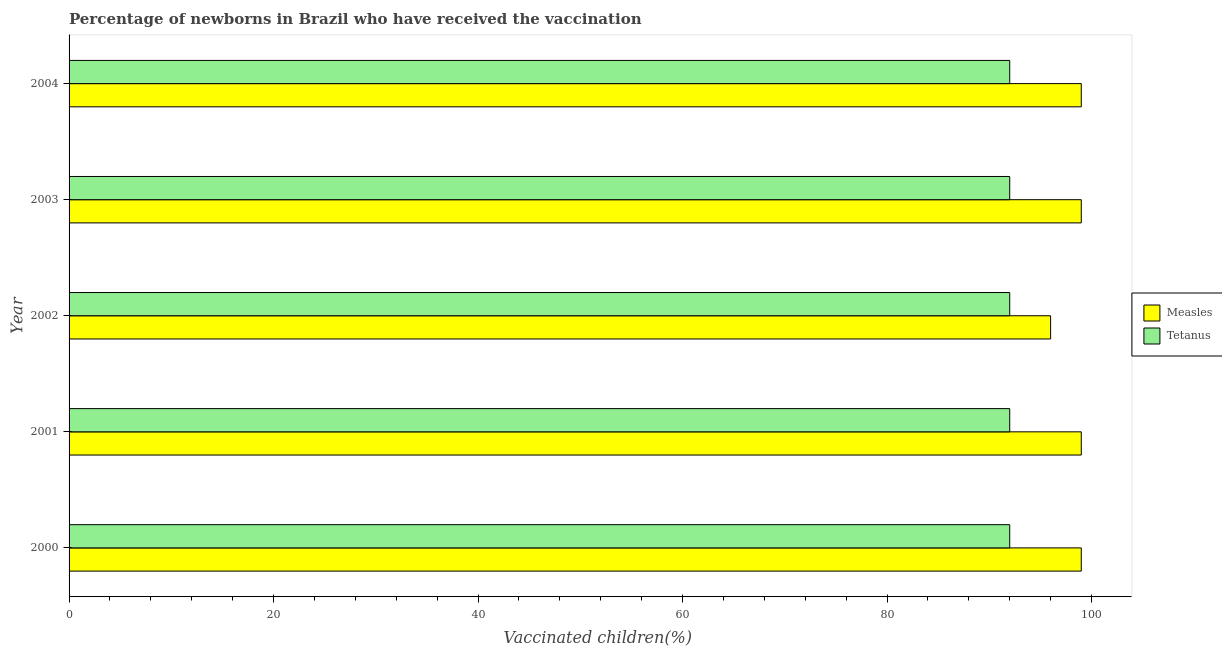How many different coloured bars are there?
Your response must be concise. 2. How many groups of bars are there?
Offer a very short reply. 5. Are the number of bars on each tick of the Y-axis equal?
Offer a terse response. Yes. How many bars are there on the 2nd tick from the top?
Provide a short and direct response. 2. In how many cases, is the number of bars for a given year not equal to the number of legend labels?
Ensure brevity in your answer.  0. What is the percentage of newborns who received vaccination for tetanus in 2004?
Your answer should be compact. 92. Across all years, what is the maximum percentage of newborns who received vaccination for measles?
Ensure brevity in your answer.  99. Across all years, what is the minimum percentage of newborns who received vaccination for tetanus?
Your answer should be very brief. 92. In which year was the percentage of newborns who received vaccination for measles minimum?
Offer a very short reply. 2002. What is the total percentage of newborns who received vaccination for measles in the graph?
Keep it short and to the point. 492. What is the difference between the percentage of newborns who received vaccination for tetanus in 2000 and the percentage of newborns who received vaccination for measles in 2001?
Make the answer very short. -7. What is the average percentage of newborns who received vaccination for tetanus per year?
Your answer should be very brief. 92. In the year 2002, what is the difference between the percentage of newborns who received vaccination for measles and percentage of newborns who received vaccination for tetanus?
Provide a succinct answer. 4. Is the percentage of newborns who received vaccination for tetanus in 2000 less than that in 2003?
Offer a terse response. No. What does the 2nd bar from the top in 2003 represents?
Make the answer very short. Measles. What does the 1st bar from the bottom in 2002 represents?
Your answer should be compact. Measles. How many years are there in the graph?
Keep it short and to the point. 5. What is the difference between two consecutive major ticks on the X-axis?
Your answer should be very brief. 20. Are the values on the major ticks of X-axis written in scientific E-notation?
Ensure brevity in your answer.  No. Where does the legend appear in the graph?
Your response must be concise. Center right. How are the legend labels stacked?
Make the answer very short. Vertical. What is the title of the graph?
Give a very brief answer. Percentage of newborns in Brazil who have received the vaccination. What is the label or title of the X-axis?
Offer a very short reply. Vaccinated children(%)
. What is the label or title of the Y-axis?
Make the answer very short. Year. What is the Vaccinated children(%)
 in Measles in 2000?
Keep it short and to the point. 99. What is the Vaccinated children(%)
 of Tetanus in 2000?
Keep it short and to the point. 92. What is the Vaccinated children(%)
 of Tetanus in 2001?
Ensure brevity in your answer.  92. What is the Vaccinated children(%)
 of Measles in 2002?
Provide a short and direct response. 96. What is the Vaccinated children(%)
 of Tetanus in 2002?
Give a very brief answer. 92. What is the Vaccinated children(%)
 of Measles in 2003?
Ensure brevity in your answer.  99. What is the Vaccinated children(%)
 of Tetanus in 2003?
Offer a very short reply. 92. What is the Vaccinated children(%)
 of Measles in 2004?
Keep it short and to the point. 99. What is the Vaccinated children(%)
 in Tetanus in 2004?
Ensure brevity in your answer.  92. Across all years, what is the maximum Vaccinated children(%)
 in Measles?
Your answer should be compact. 99. Across all years, what is the maximum Vaccinated children(%)
 in Tetanus?
Provide a succinct answer. 92. Across all years, what is the minimum Vaccinated children(%)
 of Measles?
Make the answer very short. 96. Across all years, what is the minimum Vaccinated children(%)
 in Tetanus?
Offer a very short reply. 92. What is the total Vaccinated children(%)
 of Measles in the graph?
Keep it short and to the point. 492. What is the total Vaccinated children(%)
 in Tetanus in the graph?
Provide a short and direct response. 460. What is the difference between the Vaccinated children(%)
 in Tetanus in 2000 and that in 2001?
Provide a succinct answer. 0. What is the difference between the Vaccinated children(%)
 of Tetanus in 2000 and that in 2002?
Provide a short and direct response. 0. What is the difference between the Vaccinated children(%)
 in Tetanus in 2000 and that in 2003?
Ensure brevity in your answer.  0. What is the difference between the Vaccinated children(%)
 of Measles in 2000 and that in 2004?
Your response must be concise. 0. What is the difference between the Vaccinated children(%)
 in Tetanus in 2000 and that in 2004?
Make the answer very short. 0. What is the difference between the Vaccinated children(%)
 in Measles in 2001 and that in 2002?
Your response must be concise. 3. What is the difference between the Vaccinated children(%)
 in Tetanus in 2001 and that in 2002?
Keep it short and to the point. 0. What is the difference between the Vaccinated children(%)
 in Measles in 2002 and that in 2003?
Your response must be concise. -3. What is the difference between the Vaccinated children(%)
 of Measles in 2002 and that in 2004?
Give a very brief answer. -3. What is the difference between the Vaccinated children(%)
 in Tetanus in 2002 and that in 2004?
Your answer should be compact. 0. What is the difference between the Vaccinated children(%)
 of Tetanus in 2003 and that in 2004?
Give a very brief answer. 0. What is the difference between the Vaccinated children(%)
 of Measles in 2000 and the Vaccinated children(%)
 of Tetanus in 2002?
Give a very brief answer. 7. What is the difference between the Vaccinated children(%)
 of Measles in 2000 and the Vaccinated children(%)
 of Tetanus in 2003?
Provide a succinct answer. 7. What is the difference between the Vaccinated children(%)
 in Measles in 2000 and the Vaccinated children(%)
 in Tetanus in 2004?
Ensure brevity in your answer.  7. What is the difference between the Vaccinated children(%)
 in Measles in 2001 and the Vaccinated children(%)
 in Tetanus in 2002?
Your answer should be compact. 7. What is the difference between the Vaccinated children(%)
 in Measles in 2001 and the Vaccinated children(%)
 in Tetanus in 2003?
Provide a short and direct response. 7. What is the difference between the Vaccinated children(%)
 in Measles in 2002 and the Vaccinated children(%)
 in Tetanus in 2003?
Your answer should be very brief. 4. What is the difference between the Vaccinated children(%)
 of Measles in 2002 and the Vaccinated children(%)
 of Tetanus in 2004?
Ensure brevity in your answer.  4. What is the average Vaccinated children(%)
 in Measles per year?
Provide a short and direct response. 98.4. What is the average Vaccinated children(%)
 of Tetanus per year?
Offer a very short reply. 92. In the year 2000, what is the difference between the Vaccinated children(%)
 in Measles and Vaccinated children(%)
 in Tetanus?
Keep it short and to the point. 7. In the year 2001, what is the difference between the Vaccinated children(%)
 of Measles and Vaccinated children(%)
 of Tetanus?
Give a very brief answer. 7. In the year 2002, what is the difference between the Vaccinated children(%)
 of Measles and Vaccinated children(%)
 of Tetanus?
Make the answer very short. 4. What is the ratio of the Vaccinated children(%)
 in Measles in 2000 to that in 2001?
Give a very brief answer. 1. What is the ratio of the Vaccinated children(%)
 of Tetanus in 2000 to that in 2001?
Offer a very short reply. 1. What is the ratio of the Vaccinated children(%)
 of Measles in 2000 to that in 2002?
Your response must be concise. 1.03. What is the ratio of the Vaccinated children(%)
 in Tetanus in 2000 to that in 2002?
Provide a succinct answer. 1. What is the ratio of the Vaccinated children(%)
 of Measles in 2000 to that in 2003?
Your answer should be compact. 1. What is the ratio of the Vaccinated children(%)
 in Tetanus in 2000 to that in 2004?
Provide a succinct answer. 1. What is the ratio of the Vaccinated children(%)
 in Measles in 2001 to that in 2002?
Provide a succinct answer. 1.03. What is the ratio of the Vaccinated children(%)
 in Measles in 2001 to that in 2003?
Keep it short and to the point. 1. What is the ratio of the Vaccinated children(%)
 of Measles in 2001 to that in 2004?
Keep it short and to the point. 1. What is the ratio of the Vaccinated children(%)
 in Tetanus in 2001 to that in 2004?
Provide a succinct answer. 1. What is the ratio of the Vaccinated children(%)
 of Measles in 2002 to that in 2003?
Provide a short and direct response. 0.97. What is the ratio of the Vaccinated children(%)
 in Measles in 2002 to that in 2004?
Your answer should be compact. 0.97. What is the ratio of the Vaccinated children(%)
 in Tetanus in 2002 to that in 2004?
Provide a succinct answer. 1. What is the ratio of the Vaccinated children(%)
 in Measles in 2003 to that in 2004?
Your answer should be very brief. 1. What is the ratio of the Vaccinated children(%)
 in Tetanus in 2003 to that in 2004?
Make the answer very short. 1. What is the difference between the highest and the second highest Vaccinated children(%)
 in Measles?
Make the answer very short. 0. What is the difference between the highest and the lowest Vaccinated children(%)
 of Measles?
Provide a short and direct response. 3. What is the difference between the highest and the lowest Vaccinated children(%)
 of Tetanus?
Ensure brevity in your answer.  0. 